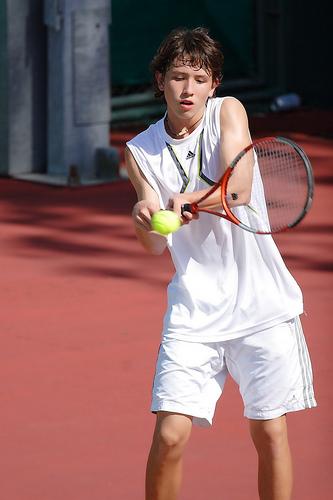Can you see the tennis player's ankles?
Concise answer only. No. What color are the boys shorts?
Concise answer only. White. What is the color of the ball?
Short answer required. Yellow. What brand of shirt is the player wearing?
Answer briefly. Adidas. 